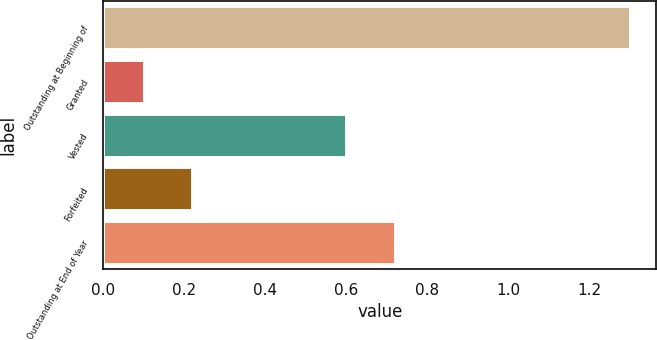Convert chart to OTSL. <chart><loc_0><loc_0><loc_500><loc_500><bar_chart><fcel>Outstanding at Beginning of<fcel>Granted<fcel>Vested<fcel>Forfeited<fcel>Outstanding at End of Year<nl><fcel>1.3<fcel>0.1<fcel>0.6<fcel>0.22<fcel>0.72<nl></chart> 